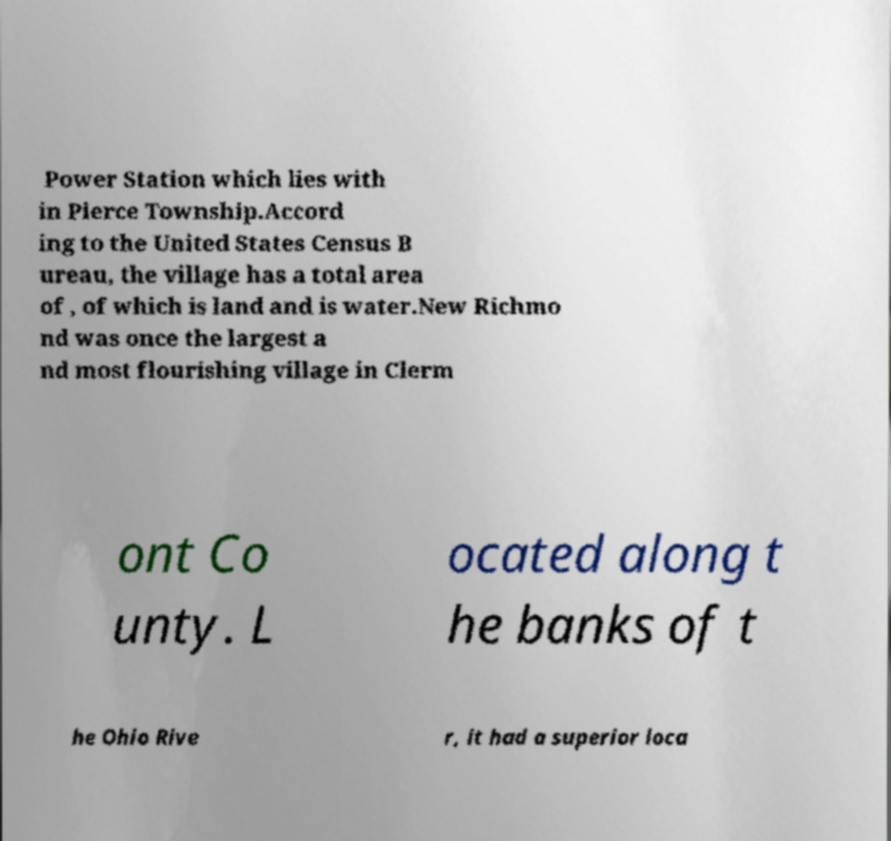Please identify and transcribe the text found in this image. Power Station which lies with in Pierce Township.Accord ing to the United States Census B ureau, the village has a total area of , of which is land and is water.New Richmo nd was once the largest a nd most flourishing village in Clerm ont Co unty. L ocated along t he banks of t he Ohio Rive r, it had a superior loca 